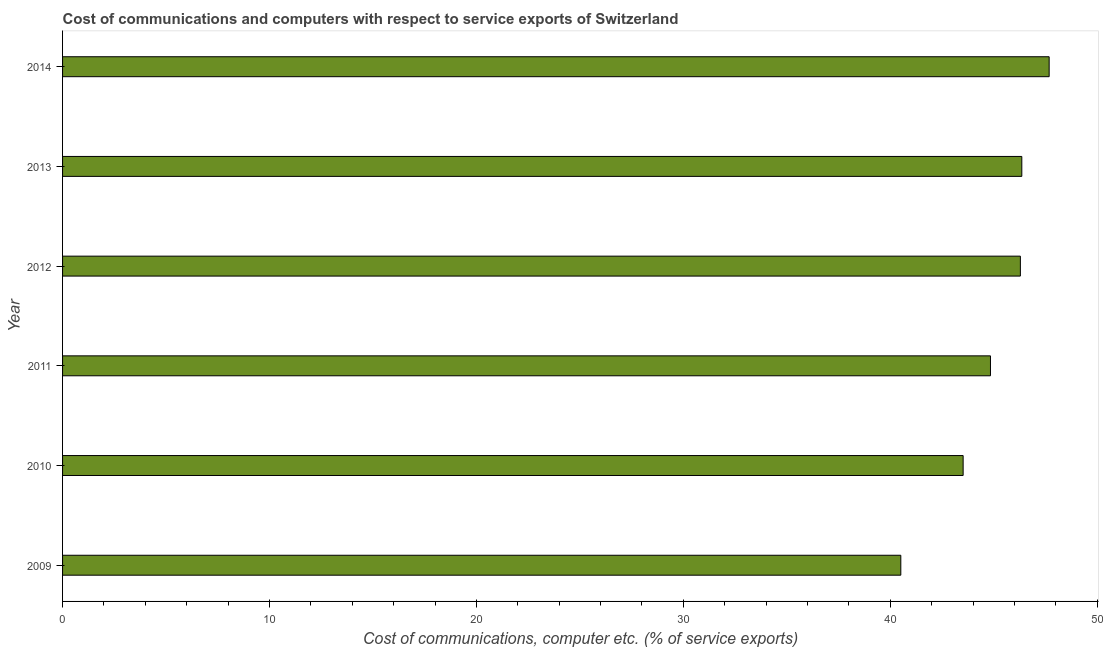Does the graph contain any zero values?
Keep it short and to the point. No. What is the title of the graph?
Your response must be concise. Cost of communications and computers with respect to service exports of Switzerland. What is the label or title of the X-axis?
Your answer should be very brief. Cost of communications, computer etc. (% of service exports). What is the cost of communications and computer in 2012?
Ensure brevity in your answer.  46.29. Across all years, what is the maximum cost of communications and computer?
Provide a succinct answer. 47.68. Across all years, what is the minimum cost of communications and computer?
Keep it short and to the point. 40.51. In which year was the cost of communications and computer minimum?
Provide a short and direct response. 2009. What is the sum of the cost of communications and computer?
Your answer should be compact. 269.18. What is the difference between the cost of communications and computer in 2011 and 2013?
Your answer should be compact. -1.51. What is the average cost of communications and computer per year?
Provide a short and direct response. 44.86. What is the median cost of communications and computer?
Provide a succinct answer. 45.56. In how many years, is the cost of communications and computer greater than 8 %?
Ensure brevity in your answer.  6. What is the ratio of the cost of communications and computer in 2011 to that in 2013?
Provide a short and direct response. 0.97. Is the cost of communications and computer in 2013 less than that in 2014?
Provide a succinct answer. Yes. Is the difference between the cost of communications and computer in 2010 and 2011 greater than the difference between any two years?
Provide a short and direct response. No. What is the difference between the highest and the second highest cost of communications and computer?
Keep it short and to the point. 1.32. Is the sum of the cost of communications and computer in 2010 and 2014 greater than the maximum cost of communications and computer across all years?
Provide a succinct answer. Yes. What is the difference between the highest and the lowest cost of communications and computer?
Your response must be concise. 7.17. What is the difference between two consecutive major ticks on the X-axis?
Your answer should be compact. 10. Are the values on the major ticks of X-axis written in scientific E-notation?
Keep it short and to the point. No. What is the Cost of communications, computer etc. (% of service exports) in 2009?
Keep it short and to the point. 40.51. What is the Cost of communications, computer etc. (% of service exports) of 2010?
Your answer should be very brief. 43.52. What is the Cost of communications, computer etc. (% of service exports) in 2011?
Give a very brief answer. 44.84. What is the Cost of communications, computer etc. (% of service exports) of 2012?
Keep it short and to the point. 46.29. What is the Cost of communications, computer etc. (% of service exports) in 2013?
Provide a short and direct response. 46.35. What is the Cost of communications, computer etc. (% of service exports) in 2014?
Your response must be concise. 47.68. What is the difference between the Cost of communications, computer etc. (% of service exports) in 2009 and 2010?
Provide a short and direct response. -3.01. What is the difference between the Cost of communications, computer etc. (% of service exports) in 2009 and 2011?
Offer a very short reply. -4.33. What is the difference between the Cost of communications, computer etc. (% of service exports) in 2009 and 2012?
Give a very brief answer. -5.78. What is the difference between the Cost of communications, computer etc. (% of service exports) in 2009 and 2013?
Offer a terse response. -5.85. What is the difference between the Cost of communications, computer etc. (% of service exports) in 2009 and 2014?
Provide a short and direct response. -7.17. What is the difference between the Cost of communications, computer etc. (% of service exports) in 2010 and 2011?
Provide a short and direct response. -1.32. What is the difference between the Cost of communications, computer etc. (% of service exports) in 2010 and 2012?
Give a very brief answer. -2.77. What is the difference between the Cost of communications, computer etc. (% of service exports) in 2010 and 2013?
Ensure brevity in your answer.  -2.84. What is the difference between the Cost of communications, computer etc. (% of service exports) in 2010 and 2014?
Offer a very short reply. -4.16. What is the difference between the Cost of communications, computer etc. (% of service exports) in 2011 and 2012?
Make the answer very short. -1.45. What is the difference between the Cost of communications, computer etc. (% of service exports) in 2011 and 2013?
Provide a succinct answer. -1.52. What is the difference between the Cost of communications, computer etc. (% of service exports) in 2011 and 2014?
Your answer should be very brief. -2.84. What is the difference between the Cost of communications, computer etc. (% of service exports) in 2012 and 2013?
Provide a succinct answer. -0.07. What is the difference between the Cost of communications, computer etc. (% of service exports) in 2012 and 2014?
Your answer should be very brief. -1.39. What is the difference between the Cost of communications, computer etc. (% of service exports) in 2013 and 2014?
Offer a very short reply. -1.32. What is the ratio of the Cost of communications, computer etc. (% of service exports) in 2009 to that in 2011?
Make the answer very short. 0.9. What is the ratio of the Cost of communications, computer etc. (% of service exports) in 2009 to that in 2012?
Make the answer very short. 0.88. What is the ratio of the Cost of communications, computer etc. (% of service exports) in 2009 to that in 2013?
Keep it short and to the point. 0.87. What is the ratio of the Cost of communications, computer etc. (% of service exports) in 2010 to that in 2012?
Offer a very short reply. 0.94. What is the ratio of the Cost of communications, computer etc. (% of service exports) in 2010 to that in 2013?
Your answer should be compact. 0.94. What is the ratio of the Cost of communications, computer etc. (% of service exports) in 2011 to that in 2014?
Offer a terse response. 0.94. What is the ratio of the Cost of communications, computer etc. (% of service exports) in 2012 to that in 2014?
Keep it short and to the point. 0.97. 